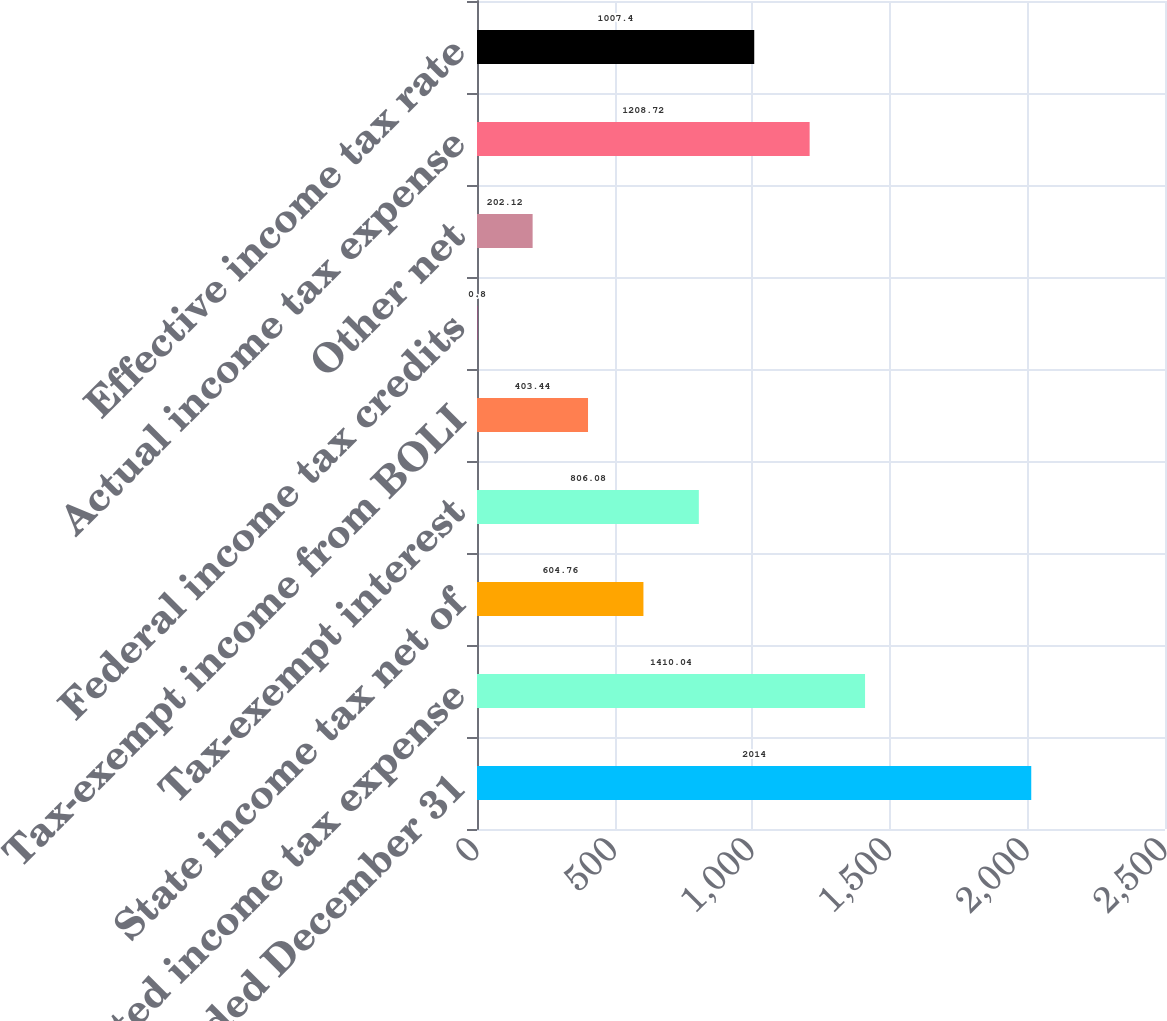<chart> <loc_0><loc_0><loc_500><loc_500><bar_chart><fcel>Years ended December 31<fcel>Expected income tax expense<fcel>State income tax net of<fcel>Tax-exempt interest<fcel>Tax-exempt income from BOLI<fcel>Federal income tax credits<fcel>Other net<fcel>Actual income tax expense<fcel>Effective income tax rate<nl><fcel>2014<fcel>1410.04<fcel>604.76<fcel>806.08<fcel>403.44<fcel>0.8<fcel>202.12<fcel>1208.72<fcel>1007.4<nl></chart> 